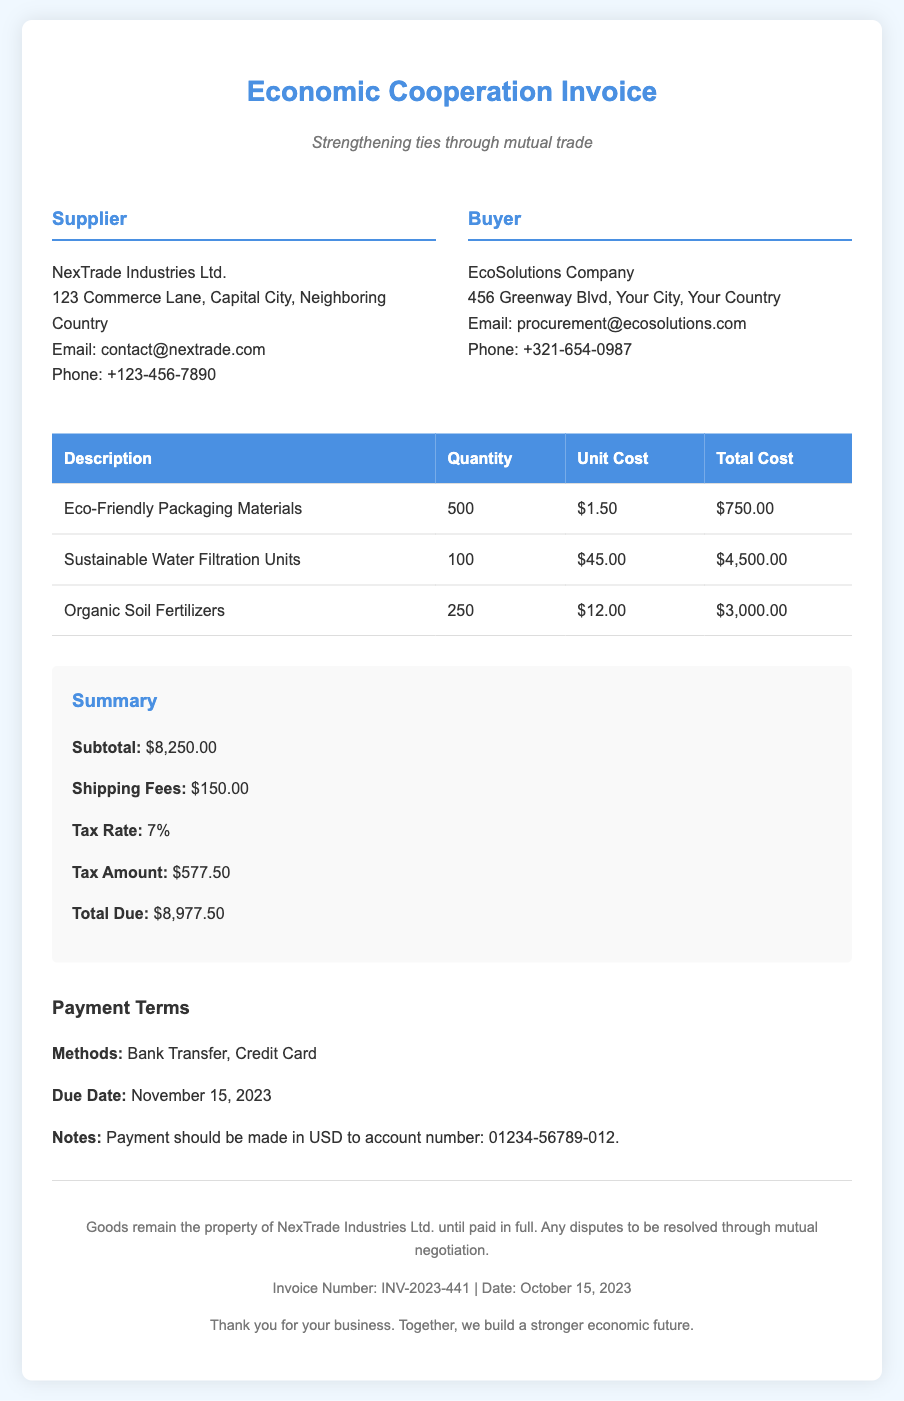What is the supplier's name? The supplier's name is listed in the company details of the document.
Answer: NexTrade Industries Ltd What is the total cost of the sustainable water filtration units? The total cost for sustainable water filtration units can be found in the itemized costs in the table.
Answer: $4,500.00 What is the due date for payment? The due date for payment is specified in the payment terms section of the document.
Answer: November 15, 2023 What is the subtotal before tax and shipping? The subtotal is explicitly mentioned in the summary section of the document.
Answer: $8,250.00 What are the payment methods accepted? The payment methods are clearly listed in the payment terms section.
Answer: Bank Transfer, Credit Card What is the shipping fee? The shipping fee is detailed in the summary section of the document next to the subtotal.
Answer: $150.00 How much is the tax amount? The tax amount is provided in the summary section and is derived from the subtotal.
Answer: $577.50 What is the total due amount? The total due amount is given prominently in the summary section of the invoice.
Answer: $8,977.50 What is the invoice number? The invoice number is noted toward the end of the document in the footer section.
Answer: INV-2023-441 